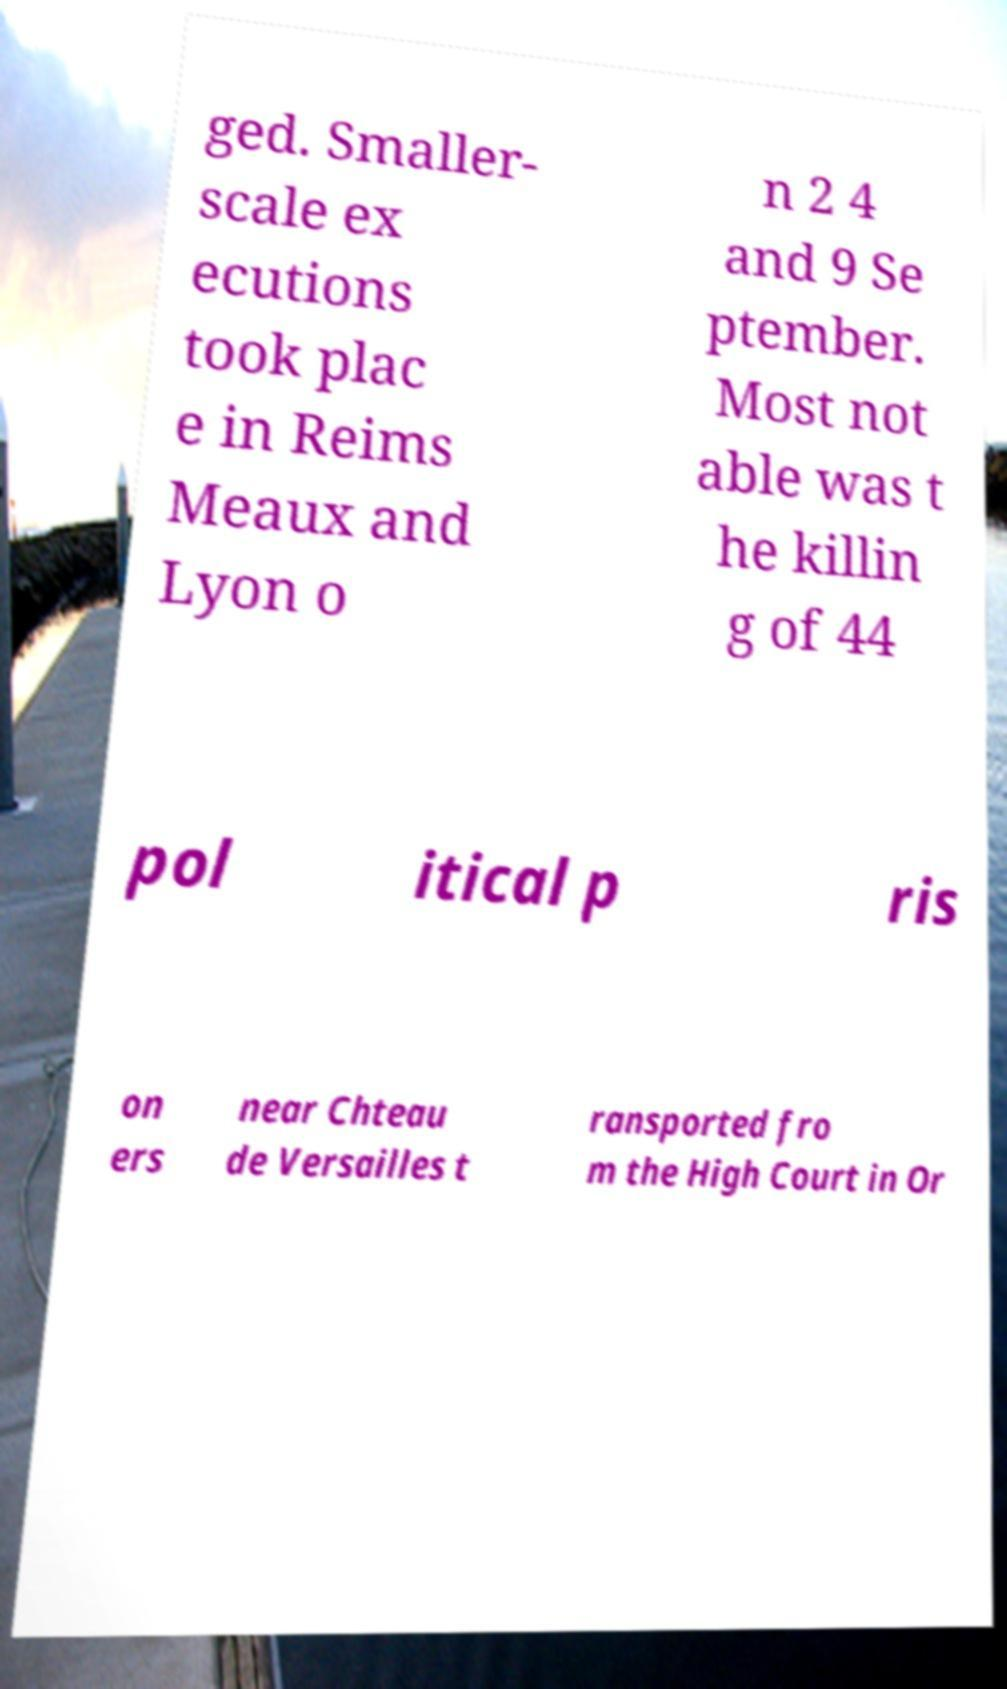Could you extract and type out the text from this image? ged. Smaller- scale ex ecutions took plac e in Reims Meaux and Lyon o n 2 4 and 9 Se ptember. Most not able was t he killin g of 44 pol itical p ris on ers near Chteau de Versailles t ransported fro m the High Court in Or 